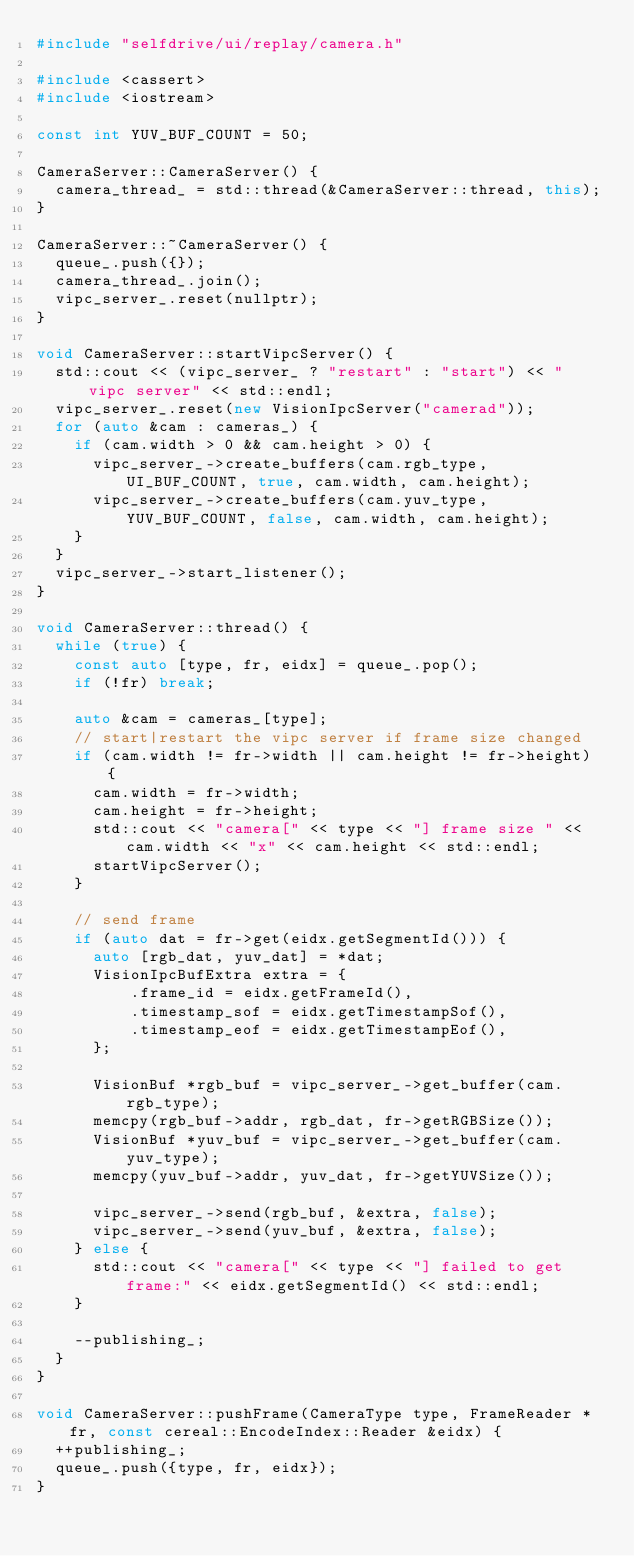<code> <loc_0><loc_0><loc_500><loc_500><_C++_>#include "selfdrive/ui/replay/camera.h"

#include <cassert>
#include <iostream>

const int YUV_BUF_COUNT = 50;

CameraServer::CameraServer() {
  camera_thread_ = std::thread(&CameraServer::thread, this);
}

CameraServer::~CameraServer() {
  queue_.push({});
  camera_thread_.join();
  vipc_server_.reset(nullptr);
}

void CameraServer::startVipcServer() {
  std::cout << (vipc_server_ ? "restart" : "start") << " vipc server" << std::endl;
  vipc_server_.reset(new VisionIpcServer("camerad"));
  for (auto &cam : cameras_) {
    if (cam.width > 0 && cam.height > 0) {
      vipc_server_->create_buffers(cam.rgb_type, UI_BUF_COUNT, true, cam.width, cam.height);
      vipc_server_->create_buffers(cam.yuv_type, YUV_BUF_COUNT, false, cam.width, cam.height);
    }
  }
  vipc_server_->start_listener();
}

void CameraServer::thread() {
  while (true) {
    const auto [type, fr, eidx] = queue_.pop();
    if (!fr) break;

    auto &cam = cameras_[type];
    // start|restart the vipc server if frame size changed
    if (cam.width != fr->width || cam.height != fr->height) {
      cam.width = fr->width;
      cam.height = fr->height;
      std::cout << "camera[" << type << "] frame size " << cam.width << "x" << cam.height << std::endl;
      startVipcServer();
    }

    // send frame
    if (auto dat = fr->get(eidx.getSegmentId())) {
      auto [rgb_dat, yuv_dat] = *dat;
      VisionIpcBufExtra extra = {
          .frame_id = eidx.getFrameId(),
          .timestamp_sof = eidx.getTimestampSof(),
          .timestamp_eof = eidx.getTimestampEof(),
      };

      VisionBuf *rgb_buf = vipc_server_->get_buffer(cam.rgb_type);
      memcpy(rgb_buf->addr, rgb_dat, fr->getRGBSize());
      VisionBuf *yuv_buf = vipc_server_->get_buffer(cam.yuv_type);
      memcpy(yuv_buf->addr, yuv_dat, fr->getYUVSize());

      vipc_server_->send(rgb_buf, &extra, false);
      vipc_server_->send(yuv_buf, &extra, false);
    } else {
      std::cout << "camera[" << type << "] failed to get frame:" << eidx.getSegmentId() << std::endl;
    }

    --publishing_;
  }
}

void CameraServer::pushFrame(CameraType type, FrameReader *fr, const cereal::EncodeIndex::Reader &eidx) {
  ++publishing_;
  queue_.push({type, fr, eidx});
}
</code> 